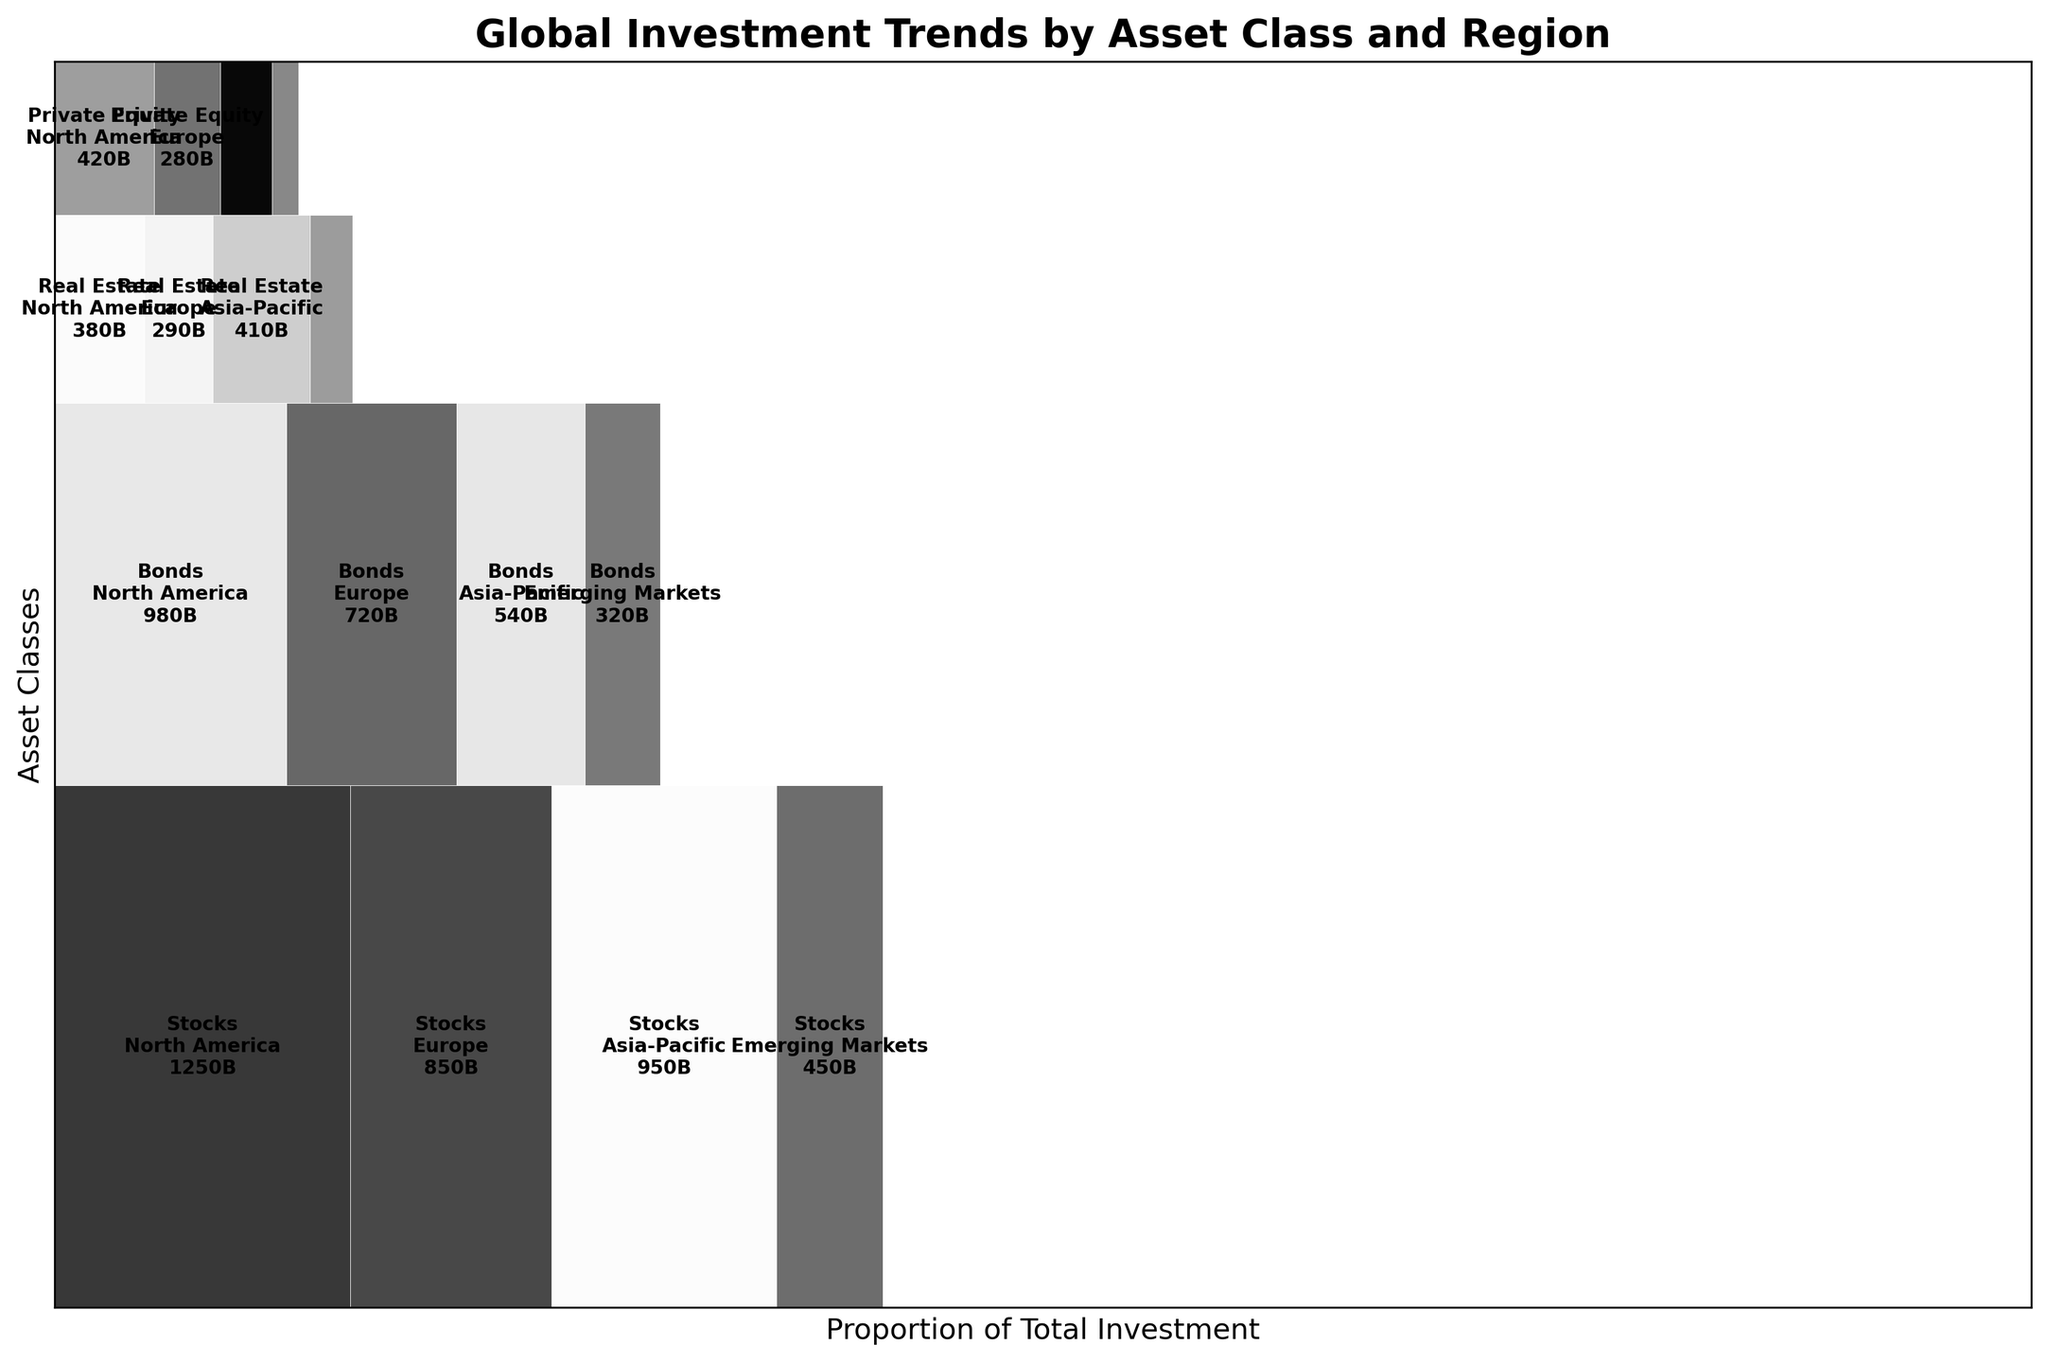What is the title of the figure? The title is typically placed at the top of a figure to describe its content. In this case, it is "Global Investment Trends by Asset Class and Region".
Answer: Global Investment Trends by Asset Class and Region Which asset class has the highest total investment? To determine this, we need to compare the total heights of the rectangles representing each asset class. "Stocks" has the tallest collective height, indicating the highest total investment.
Answer: Stocks Which region has the lowest investment in Real Estate? Look at the width of the sections corresponding to Real Estate. The smallest width denotes the lowest investment. Emerging Markets have the smallest width.
Answer: Emerging Markets Compare the total investment in North America for Bonds and Real Estate. Which one is higher? For this, we have to observe the widths of the North America sections in Bonds and Real Estate. The width for Bonds is significantly larger than Real Estate.
Answer: Bonds What is the total investment in Private Equity in the Asia-Pacific region? Locate the section for Private Equity and identify the part corresponding to Asia-Pacific. The label within the section gives the investment amount.
Answer: 220B How does the investment in Asia-Pacific Stock compare to Europe Stock? Compare the widths of the Asia-Pacific section in Stocks to that of Europe. Asia-Pacific has a wider section indicating higher investment.
Answer: Asia-Pacific If combined, would the investments in Asia-Pacific Bonds and Real Estate be more than the investments in North America Real Estate? Sum the amounts for Asia-Pacific Bonds (540B) and Real Estate (410B) and compare it with North America Real Estate (380B). 540B + 410B = 950B, which is greater.
Answer: Yes Which asset class has the most balanced investment across all regions? Check the sections for each asset class and see which one has relatively similar widths across North America, Europe, Asia-Pacific, and Emerging Markets. Real Estate shows a more balanced distribution than others.
Answer: Real Estate What is the investment amount for Bonds in Emerging Markets? Locate the Bonds section and find the specific subsection for Emerging Markets. The investment amount is labeled there.
Answer: 320B 